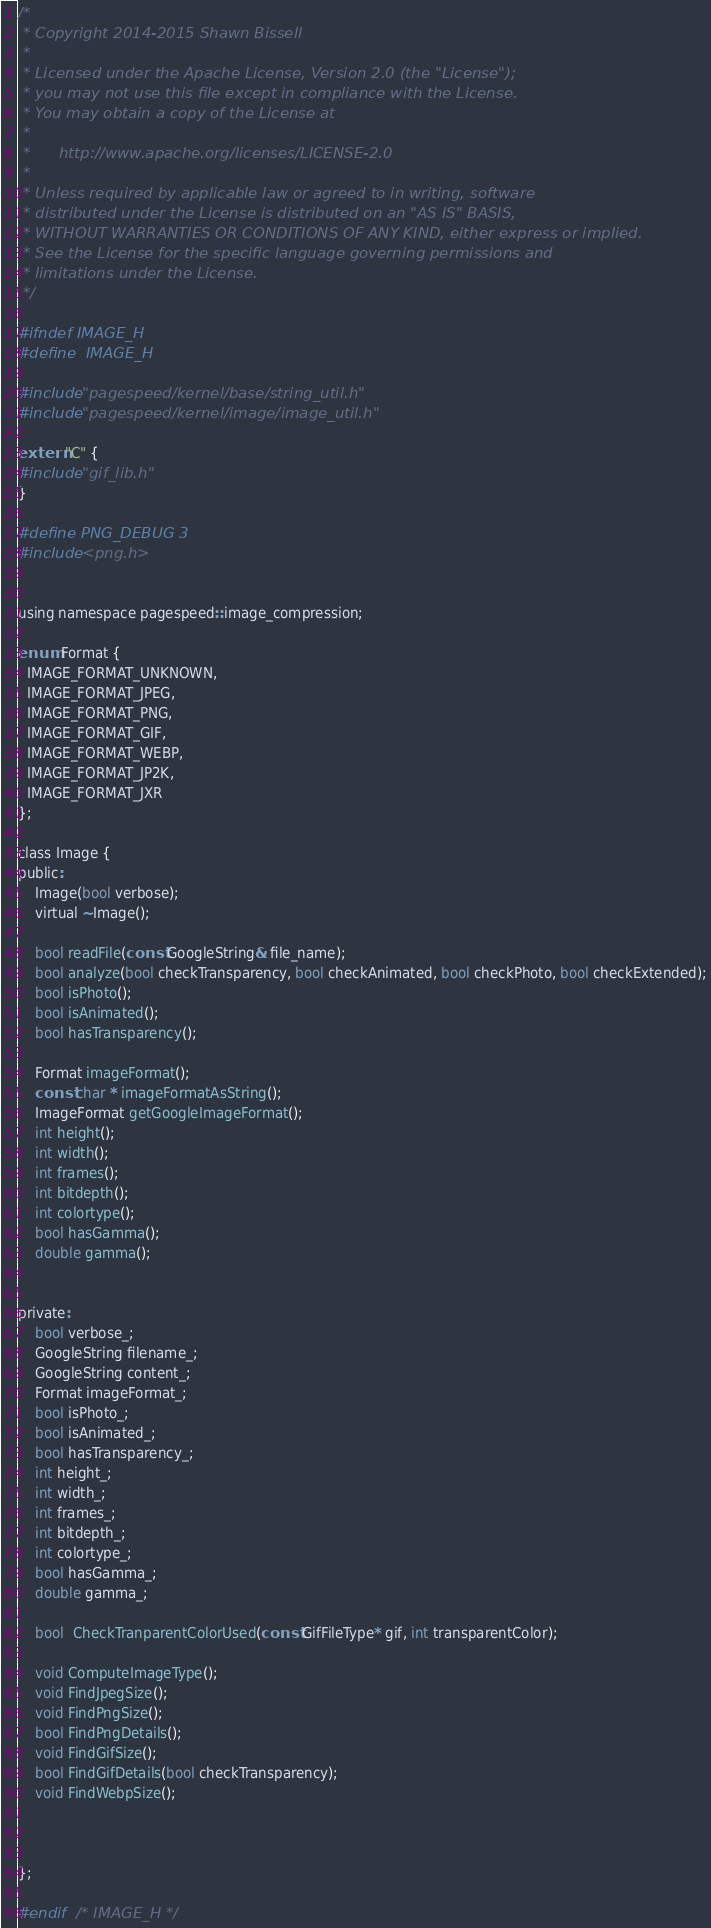<code> <loc_0><loc_0><loc_500><loc_500><_C_>/*
 * Copyright 2014-2015 Shawn Bissell 
 *
 * Licensed under the Apache License, Version 2.0 (the "License");
 * you may not use this file except in compliance with the License.
 * You may obtain a copy of the License at
 *
 *      http://www.apache.org/licenses/LICENSE-2.0
 *
 * Unless required by applicable law or agreed to in writing, software
 * distributed under the License is distributed on an "AS IS" BASIS,
 * WITHOUT WARRANTIES OR CONDITIONS OF ANY KIND, either express or implied.
 * See the License for the specific language governing permissions and
 * limitations under the License.
 */

#ifndef IMAGE_H
#define	IMAGE_H

#include "pagespeed/kernel/base/string_util.h"
#include "pagespeed/kernel/image/image_util.h"

extern "C" {
#include "gif_lib.h"    
}

#define PNG_DEBUG 3
#include <png.h>


using namespace pagespeed::image_compression;

enum Format {
  IMAGE_FORMAT_UNKNOWN,
  IMAGE_FORMAT_JPEG,
  IMAGE_FORMAT_PNG,
  IMAGE_FORMAT_GIF,
  IMAGE_FORMAT_WEBP,
  IMAGE_FORMAT_JP2K,
  IMAGE_FORMAT_JXR
};

class Image {
public:
    Image(bool verbose);
    virtual ~Image();
    
    bool readFile(const GoogleString& file_name);
    bool analyze(bool checkTransparency, bool checkAnimated, bool checkPhoto, bool checkExtended);
    bool isPhoto();
    bool isAnimated();
    bool hasTransparency();
    
    Format imageFormat();
    const char * imageFormatAsString();
    ImageFormat getGoogleImageFormat();
    int height();
    int width();
    int frames();
    int bitdepth();
    int colortype();
    bool hasGamma();
    double gamma();
 
    
private:
    bool verbose_;
    GoogleString filename_;
    GoogleString content_;
    Format imageFormat_;
    bool isPhoto_;
    bool isAnimated_;
    bool hasTransparency_;
    int height_;
    int width_;
    int frames_;
    int bitdepth_;
    int colortype_;
    bool hasGamma_;
    double gamma_;
    
    bool  CheckTranparentColorUsed(const GifFileType* gif, int transparentColor);
    
    void ComputeImageType();
    void FindJpegSize();
    void FindPngSize();
    bool FindPngDetails();
    void FindGifSize();
    bool FindGifDetails(bool checkTransparency);
    void FindWebpSize();
    
      

};

#endif	/* IMAGE_H */

</code> 